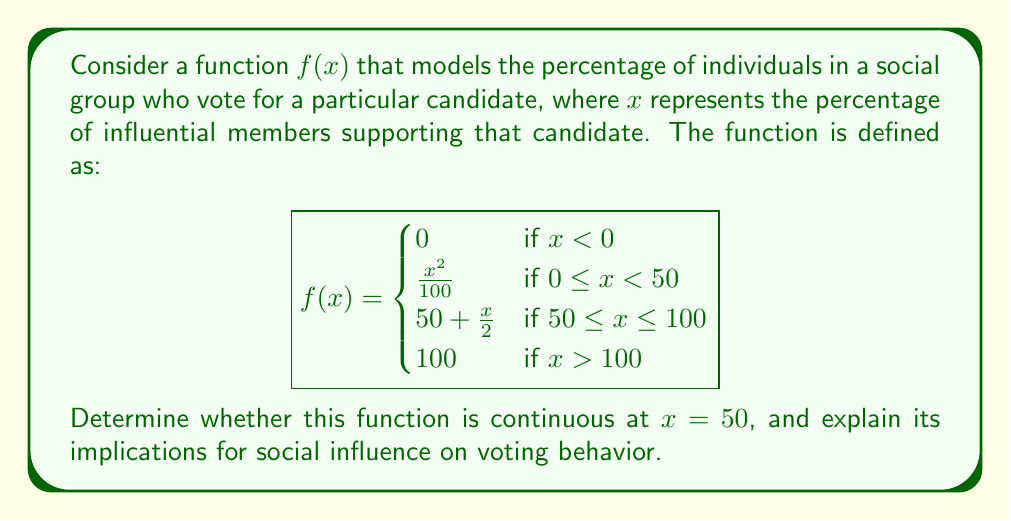Could you help me with this problem? To determine if the function $f(x)$ is continuous at $x = 50$, we need to check three conditions:

1. $f(x)$ is defined at $x = 50$
2. $\lim_{x \to 50^-} f(x)$ exists
3. $\lim_{x \to 50^+} f(x)$ exists
4. $\lim_{x \to 50^-} f(x) = \lim_{x \to 50^+} f(x) = f(50)$

Let's check each condition:

1. $f(50)$ is defined: $f(50) = 50 + \frac{50}{2} = 75$

2. Left-hand limit:
   $\lim_{x \to 50^-} f(x) = \lim_{x \to 50^-} \frac{x^2}{100} = \frac{50^2}{100} = 25$

3. Right-hand limit:
   $\lim_{x \to 50^+} f(x) = \lim_{x \to 50^+} (50 + \frac{x}{2}) = 50 + \frac{50}{2} = 75$

4. Comparing the limits and function value:
   $\lim_{x \to 50^-} f(x) = 25 \neq 75 = \lim_{x \to 50^+} f(x) = f(50)$

Since the left-hand limit does not equal the right-hand limit and the function value at $x = 50$, the function is not continuous at $x = 50$.

Implications for social influence on voting behavior:

This discontinuity at $x = 50$ suggests a critical threshold in social influence. When the percentage of influential members supporting a candidate reaches 50%, there's a sudden jump in the overall group's voting behavior. This could represent a tipping point where social pressure or perceived majority opinion causes a rapid shift in voting intentions.

The piecewise nature of the function also implies different dynamics of influence:
- Below 50%, the influence grows quadratically, suggesting a slow initial uptake followed by accelerating influence.
- Above 50%, the influence grows linearly, indicating a more steady and predictable increase in support.

This model captures the complex, non-linear nature of social influence on voting behavior, highlighting the importance of reaching a critical mass of influential supporters to trigger a significant shift in group voting patterns.
Answer: The function $f(x)$ is not continuous at $x = 50$. There is a jump discontinuity, with $\lim_{x \to 50^-} f(x) = 25$ and $\lim_{x \to 50^+} f(x) = f(50) = 75$. 